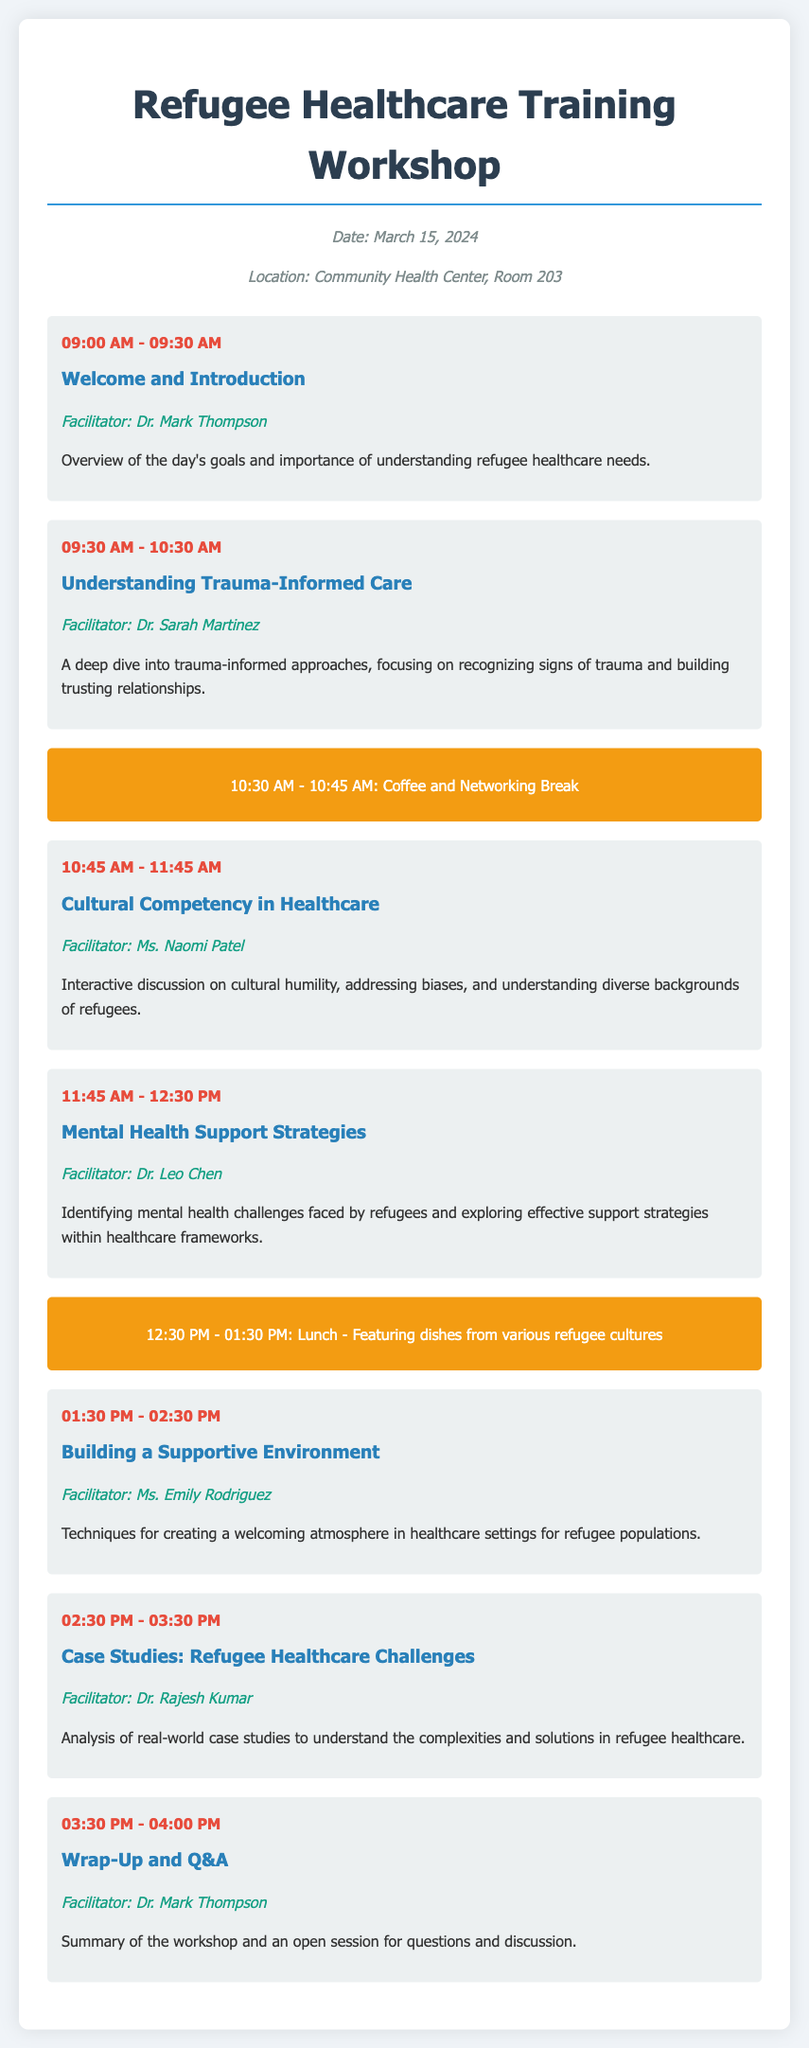What date is the workshop scheduled for? The workshop date is explicitly stated in the document, which is March 15, 2024.
Answer: March 15, 2024 Who is facilitating the session on trauma-informed care? The facilitator for the trauma-informed care session is mentioned as Dr. Sarah Martinez.
Answer: Dr. Sarah Martinez What time does the lunch break begin? The document specifies the lunch time, which starts at 12:30 PM.
Answer: 12:30 PM What is a key topic discussed in the session led by Ms. Naomi Patel? The session led by Ms. Naomi Patel focuses on cultural humility and understanding diverse backgrounds.
Answer: Cultural Competency How long is the coffee and networking break? The document states the duration of the coffee and networking break is from 10:30 AM to 10:45 AM, which is 15 minutes.
Answer: 15 minutes What topic is covered in the final session of the workshop? The final session is summarized in the document as a wrap-up and Q&A session.
Answer: Wrap-Up and Q&A Which facilitator addresses mental health support strategies? The document names Dr. Leo Chen as the facilitator for mental health support strategies.
Answer: Dr. Leo Chen What is included in the lunch menu? The document notes that lunch will feature dishes from various refugee cultures.
Answer: Dishes from various refugee cultures 